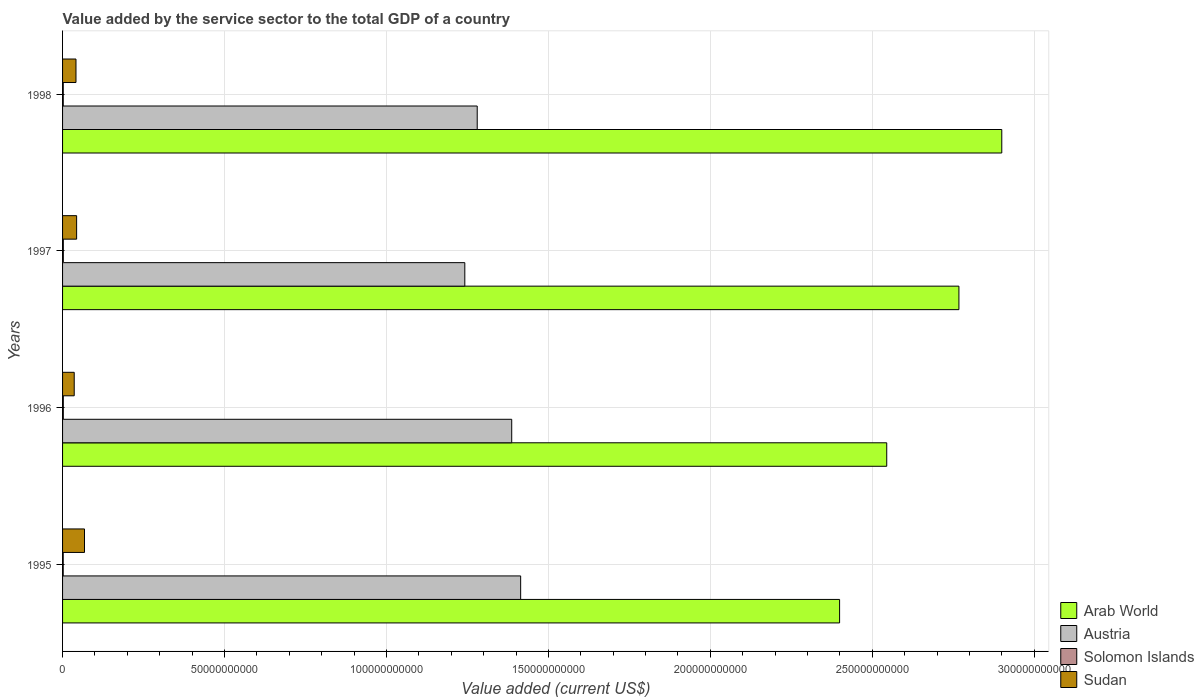How many groups of bars are there?
Make the answer very short. 4. Are the number of bars per tick equal to the number of legend labels?
Offer a very short reply. Yes. Are the number of bars on each tick of the Y-axis equal?
Your answer should be compact. Yes. What is the label of the 3rd group of bars from the top?
Your response must be concise. 1996. In how many cases, is the number of bars for a given year not equal to the number of legend labels?
Your answer should be compact. 0. What is the value added by the service sector to the total GDP in Arab World in 1998?
Keep it short and to the point. 2.90e+11. Across all years, what is the maximum value added by the service sector to the total GDP in Sudan?
Make the answer very short. 6.77e+09. Across all years, what is the minimum value added by the service sector to the total GDP in Solomon Islands?
Keep it short and to the point. 2.01e+08. In which year was the value added by the service sector to the total GDP in Solomon Islands maximum?
Provide a succinct answer. 1997. What is the total value added by the service sector to the total GDP in Sudan in the graph?
Offer a very short reply. 1.89e+1. What is the difference between the value added by the service sector to the total GDP in Arab World in 1995 and that in 1997?
Make the answer very short. -3.68e+1. What is the difference between the value added by the service sector to the total GDP in Austria in 1996 and the value added by the service sector to the total GDP in Arab World in 1997?
Offer a very short reply. -1.38e+11. What is the average value added by the service sector to the total GDP in Sudan per year?
Your response must be concise. 4.71e+09. In the year 1997, what is the difference between the value added by the service sector to the total GDP in Sudan and value added by the service sector to the total GDP in Arab World?
Ensure brevity in your answer.  -2.72e+11. In how many years, is the value added by the service sector to the total GDP in Austria greater than 70000000000 US$?
Your response must be concise. 4. What is the ratio of the value added by the service sector to the total GDP in Sudan in 1995 to that in 1998?
Your response must be concise. 1.63. What is the difference between the highest and the second highest value added by the service sector to the total GDP in Sudan?
Offer a very short reply. 2.43e+09. What is the difference between the highest and the lowest value added by the service sector to the total GDP in Arab World?
Provide a short and direct response. 5.01e+1. In how many years, is the value added by the service sector to the total GDP in Austria greater than the average value added by the service sector to the total GDP in Austria taken over all years?
Offer a terse response. 2. Is it the case that in every year, the sum of the value added by the service sector to the total GDP in Austria and value added by the service sector to the total GDP in Sudan is greater than the sum of value added by the service sector to the total GDP in Arab World and value added by the service sector to the total GDP in Solomon Islands?
Your answer should be very brief. No. What does the 4th bar from the top in 1997 represents?
Your answer should be very brief. Arab World. What does the 3rd bar from the bottom in 1996 represents?
Keep it short and to the point. Solomon Islands. Is it the case that in every year, the sum of the value added by the service sector to the total GDP in Arab World and value added by the service sector to the total GDP in Sudan is greater than the value added by the service sector to the total GDP in Solomon Islands?
Ensure brevity in your answer.  Yes. How many bars are there?
Make the answer very short. 16. Are all the bars in the graph horizontal?
Provide a succinct answer. Yes. How many years are there in the graph?
Make the answer very short. 4. Where does the legend appear in the graph?
Your response must be concise. Bottom right. What is the title of the graph?
Give a very brief answer. Value added by the service sector to the total GDP of a country. What is the label or title of the X-axis?
Offer a terse response. Value added (current US$). What is the label or title of the Y-axis?
Keep it short and to the point. Years. What is the Value added (current US$) in Arab World in 1995?
Your answer should be compact. 2.40e+11. What is the Value added (current US$) of Austria in 1995?
Make the answer very short. 1.41e+11. What is the Value added (current US$) of Solomon Islands in 1995?
Your answer should be very brief. 2.01e+08. What is the Value added (current US$) in Sudan in 1995?
Your answer should be compact. 6.77e+09. What is the Value added (current US$) of Arab World in 1996?
Provide a succinct answer. 2.54e+11. What is the Value added (current US$) in Austria in 1996?
Ensure brevity in your answer.  1.39e+11. What is the Value added (current US$) in Solomon Islands in 1996?
Your answer should be compact. 2.31e+08. What is the Value added (current US$) of Sudan in 1996?
Provide a short and direct response. 3.60e+09. What is the Value added (current US$) in Arab World in 1997?
Your answer should be compact. 2.77e+11. What is the Value added (current US$) in Austria in 1997?
Ensure brevity in your answer.  1.24e+11. What is the Value added (current US$) of Solomon Islands in 1997?
Provide a succinct answer. 2.37e+08. What is the Value added (current US$) of Sudan in 1997?
Your answer should be very brief. 4.34e+09. What is the Value added (current US$) of Arab World in 1998?
Keep it short and to the point. 2.90e+11. What is the Value added (current US$) of Austria in 1998?
Your answer should be very brief. 1.28e+11. What is the Value added (current US$) in Solomon Islands in 1998?
Your response must be concise. 2.17e+08. What is the Value added (current US$) of Sudan in 1998?
Your answer should be compact. 4.14e+09. Across all years, what is the maximum Value added (current US$) of Arab World?
Keep it short and to the point. 2.90e+11. Across all years, what is the maximum Value added (current US$) in Austria?
Give a very brief answer. 1.41e+11. Across all years, what is the maximum Value added (current US$) in Solomon Islands?
Your response must be concise. 2.37e+08. Across all years, what is the maximum Value added (current US$) in Sudan?
Offer a very short reply. 6.77e+09. Across all years, what is the minimum Value added (current US$) in Arab World?
Keep it short and to the point. 2.40e+11. Across all years, what is the minimum Value added (current US$) of Austria?
Provide a short and direct response. 1.24e+11. Across all years, what is the minimum Value added (current US$) of Solomon Islands?
Keep it short and to the point. 2.01e+08. Across all years, what is the minimum Value added (current US$) of Sudan?
Your answer should be very brief. 3.60e+09. What is the total Value added (current US$) in Arab World in the graph?
Give a very brief answer. 1.06e+12. What is the total Value added (current US$) of Austria in the graph?
Provide a succinct answer. 5.32e+11. What is the total Value added (current US$) in Solomon Islands in the graph?
Offer a very short reply. 8.87e+08. What is the total Value added (current US$) of Sudan in the graph?
Your answer should be very brief. 1.89e+1. What is the difference between the Value added (current US$) in Arab World in 1995 and that in 1996?
Keep it short and to the point. -1.46e+1. What is the difference between the Value added (current US$) of Austria in 1995 and that in 1996?
Your response must be concise. 2.76e+09. What is the difference between the Value added (current US$) in Solomon Islands in 1995 and that in 1996?
Your answer should be very brief. -2.99e+07. What is the difference between the Value added (current US$) of Sudan in 1995 and that in 1996?
Provide a short and direct response. 3.17e+09. What is the difference between the Value added (current US$) of Arab World in 1995 and that in 1997?
Your answer should be very brief. -3.68e+1. What is the difference between the Value added (current US$) in Austria in 1995 and that in 1997?
Offer a very short reply. 1.72e+1. What is the difference between the Value added (current US$) of Solomon Islands in 1995 and that in 1997?
Offer a very short reply. -3.56e+07. What is the difference between the Value added (current US$) of Sudan in 1995 and that in 1997?
Your answer should be very brief. 2.43e+09. What is the difference between the Value added (current US$) of Arab World in 1995 and that in 1998?
Your answer should be compact. -5.01e+1. What is the difference between the Value added (current US$) in Austria in 1995 and that in 1998?
Offer a very short reply. 1.34e+1. What is the difference between the Value added (current US$) in Solomon Islands in 1995 and that in 1998?
Ensure brevity in your answer.  -1.59e+07. What is the difference between the Value added (current US$) of Sudan in 1995 and that in 1998?
Provide a short and direct response. 2.63e+09. What is the difference between the Value added (current US$) of Arab World in 1996 and that in 1997?
Your response must be concise. -2.23e+1. What is the difference between the Value added (current US$) of Austria in 1996 and that in 1997?
Keep it short and to the point. 1.45e+1. What is the difference between the Value added (current US$) of Solomon Islands in 1996 and that in 1997?
Keep it short and to the point. -5.67e+06. What is the difference between the Value added (current US$) in Sudan in 1996 and that in 1997?
Make the answer very short. -7.44e+08. What is the difference between the Value added (current US$) in Arab World in 1996 and that in 1998?
Offer a terse response. -3.55e+1. What is the difference between the Value added (current US$) of Austria in 1996 and that in 1998?
Your answer should be compact. 1.07e+1. What is the difference between the Value added (current US$) in Solomon Islands in 1996 and that in 1998?
Your answer should be very brief. 1.40e+07. What is the difference between the Value added (current US$) in Sudan in 1996 and that in 1998?
Give a very brief answer. -5.45e+08. What is the difference between the Value added (current US$) of Arab World in 1997 and that in 1998?
Your answer should be very brief. -1.32e+1. What is the difference between the Value added (current US$) of Austria in 1997 and that in 1998?
Offer a very short reply. -3.83e+09. What is the difference between the Value added (current US$) of Solomon Islands in 1997 and that in 1998?
Give a very brief answer. 1.97e+07. What is the difference between the Value added (current US$) of Sudan in 1997 and that in 1998?
Your answer should be very brief. 1.99e+08. What is the difference between the Value added (current US$) in Arab World in 1995 and the Value added (current US$) in Austria in 1996?
Your answer should be compact. 1.01e+11. What is the difference between the Value added (current US$) in Arab World in 1995 and the Value added (current US$) in Solomon Islands in 1996?
Ensure brevity in your answer.  2.40e+11. What is the difference between the Value added (current US$) of Arab World in 1995 and the Value added (current US$) of Sudan in 1996?
Keep it short and to the point. 2.36e+11. What is the difference between the Value added (current US$) of Austria in 1995 and the Value added (current US$) of Solomon Islands in 1996?
Keep it short and to the point. 1.41e+11. What is the difference between the Value added (current US$) in Austria in 1995 and the Value added (current US$) in Sudan in 1996?
Offer a very short reply. 1.38e+11. What is the difference between the Value added (current US$) of Solomon Islands in 1995 and the Value added (current US$) of Sudan in 1996?
Provide a succinct answer. -3.40e+09. What is the difference between the Value added (current US$) of Arab World in 1995 and the Value added (current US$) of Austria in 1997?
Give a very brief answer. 1.16e+11. What is the difference between the Value added (current US$) in Arab World in 1995 and the Value added (current US$) in Solomon Islands in 1997?
Offer a very short reply. 2.40e+11. What is the difference between the Value added (current US$) in Arab World in 1995 and the Value added (current US$) in Sudan in 1997?
Your response must be concise. 2.36e+11. What is the difference between the Value added (current US$) of Austria in 1995 and the Value added (current US$) of Solomon Islands in 1997?
Offer a very short reply. 1.41e+11. What is the difference between the Value added (current US$) of Austria in 1995 and the Value added (current US$) of Sudan in 1997?
Keep it short and to the point. 1.37e+11. What is the difference between the Value added (current US$) in Solomon Islands in 1995 and the Value added (current US$) in Sudan in 1997?
Keep it short and to the point. -4.14e+09. What is the difference between the Value added (current US$) of Arab World in 1995 and the Value added (current US$) of Austria in 1998?
Make the answer very short. 1.12e+11. What is the difference between the Value added (current US$) in Arab World in 1995 and the Value added (current US$) in Solomon Islands in 1998?
Provide a succinct answer. 2.40e+11. What is the difference between the Value added (current US$) in Arab World in 1995 and the Value added (current US$) in Sudan in 1998?
Provide a short and direct response. 2.36e+11. What is the difference between the Value added (current US$) of Austria in 1995 and the Value added (current US$) of Solomon Islands in 1998?
Ensure brevity in your answer.  1.41e+11. What is the difference between the Value added (current US$) of Austria in 1995 and the Value added (current US$) of Sudan in 1998?
Your response must be concise. 1.37e+11. What is the difference between the Value added (current US$) of Solomon Islands in 1995 and the Value added (current US$) of Sudan in 1998?
Offer a very short reply. -3.94e+09. What is the difference between the Value added (current US$) of Arab World in 1996 and the Value added (current US$) of Austria in 1997?
Your answer should be compact. 1.30e+11. What is the difference between the Value added (current US$) in Arab World in 1996 and the Value added (current US$) in Solomon Islands in 1997?
Your answer should be compact. 2.54e+11. What is the difference between the Value added (current US$) in Arab World in 1996 and the Value added (current US$) in Sudan in 1997?
Provide a succinct answer. 2.50e+11. What is the difference between the Value added (current US$) in Austria in 1996 and the Value added (current US$) in Solomon Islands in 1997?
Offer a terse response. 1.38e+11. What is the difference between the Value added (current US$) in Austria in 1996 and the Value added (current US$) in Sudan in 1997?
Your answer should be compact. 1.34e+11. What is the difference between the Value added (current US$) in Solomon Islands in 1996 and the Value added (current US$) in Sudan in 1997?
Ensure brevity in your answer.  -4.11e+09. What is the difference between the Value added (current US$) in Arab World in 1996 and the Value added (current US$) in Austria in 1998?
Your answer should be compact. 1.26e+11. What is the difference between the Value added (current US$) in Arab World in 1996 and the Value added (current US$) in Solomon Islands in 1998?
Provide a succinct answer. 2.54e+11. What is the difference between the Value added (current US$) of Arab World in 1996 and the Value added (current US$) of Sudan in 1998?
Offer a very short reply. 2.50e+11. What is the difference between the Value added (current US$) in Austria in 1996 and the Value added (current US$) in Solomon Islands in 1998?
Offer a terse response. 1.38e+11. What is the difference between the Value added (current US$) in Austria in 1996 and the Value added (current US$) in Sudan in 1998?
Provide a short and direct response. 1.35e+11. What is the difference between the Value added (current US$) in Solomon Islands in 1996 and the Value added (current US$) in Sudan in 1998?
Offer a very short reply. -3.91e+09. What is the difference between the Value added (current US$) in Arab World in 1997 and the Value added (current US$) in Austria in 1998?
Make the answer very short. 1.49e+11. What is the difference between the Value added (current US$) in Arab World in 1997 and the Value added (current US$) in Solomon Islands in 1998?
Offer a terse response. 2.77e+11. What is the difference between the Value added (current US$) in Arab World in 1997 and the Value added (current US$) in Sudan in 1998?
Keep it short and to the point. 2.73e+11. What is the difference between the Value added (current US$) in Austria in 1997 and the Value added (current US$) in Solomon Islands in 1998?
Your answer should be compact. 1.24e+11. What is the difference between the Value added (current US$) of Austria in 1997 and the Value added (current US$) of Sudan in 1998?
Your answer should be very brief. 1.20e+11. What is the difference between the Value added (current US$) in Solomon Islands in 1997 and the Value added (current US$) in Sudan in 1998?
Give a very brief answer. -3.91e+09. What is the average Value added (current US$) in Arab World per year?
Provide a short and direct response. 2.65e+11. What is the average Value added (current US$) of Austria per year?
Ensure brevity in your answer.  1.33e+11. What is the average Value added (current US$) in Solomon Islands per year?
Your answer should be compact. 2.22e+08. What is the average Value added (current US$) of Sudan per year?
Provide a succinct answer. 4.71e+09. In the year 1995, what is the difference between the Value added (current US$) in Arab World and Value added (current US$) in Austria?
Offer a very short reply. 9.85e+1. In the year 1995, what is the difference between the Value added (current US$) of Arab World and Value added (current US$) of Solomon Islands?
Keep it short and to the point. 2.40e+11. In the year 1995, what is the difference between the Value added (current US$) in Arab World and Value added (current US$) in Sudan?
Offer a terse response. 2.33e+11. In the year 1995, what is the difference between the Value added (current US$) in Austria and Value added (current US$) in Solomon Islands?
Your answer should be compact. 1.41e+11. In the year 1995, what is the difference between the Value added (current US$) in Austria and Value added (current US$) in Sudan?
Your answer should be compact. 1.35e+11. In the year 1995, what is the difference between the Value added (current US$) in Solomon Islands and Value added (current US$) in Sudan?
Ensure brevity in your answer.  -6.57e+09. In the year 1996, what is the difference between the Value added (current US$) of Arab World and Value added (current US$) of Austria?
Offer a very short reply. 1.16e+11. In the year 1996, what is the difference between the Value added (current US$) of Arab World and Value added (current US$) of Solomon Islands?
Provide a short and direct response. 2.54e+11. In the year 1996, what is the difference between the Value added (current US$) of Arab World and Value added (current US$) of Sudan?
Make the answer very short. 2.51e+11. In the year 1996, what is the difference between the Value added (current US$) in Austria and Value added (current US$) in Solomon Islands?
Your response must be concise. 1.38e+11. In the year 1996, what is the difference between the Value added (current US$) in Austria and Value added (current US$) in Sudan?
Make the answer very short. 1.35e+11. In the year 1996, what is the difference between the Value added (current US$) of Solomon Islands and Value added (current US$) of Sudan?
Ensure brevity in your answer.  -3.37e+09. In the year 1997, what is the difference between the Value added (current US$) in Arab World and Value added (current US$) in Austria?
Keep it short and to the point. 1.53e+11. In the year 1997, what is the difference between the Value added (current US$) of Arab World and Value added (current US$) of Solomon Islands?
Provide a succinct answer. 2.77e+11. In the year 1997, what is the difference between the Value added (current US$) in Arab World and Value added (current US$) in Sudan?
Provide a short and direct response. 2.72e+11. In the year 1997, what is the difference between the Value added (current US$) of Austria and Value added (current US$) of Solomon Islands?
Make the answer very short. 1.24e+11. In the year 1997, what is the difference between the Value added (current US$) of Austria and Value added (current US$) of Sudan?
Offer a terse response. 1.20e+11. In the year 1997, what is the difference between the Value added (current US$) of Solomon Islands and Value added (current US$) of Sudan?
Offer a very short reply. -4.10e+09. In the year 1998, what is the difference between the Value added (current US$) of Arab World and Value added (current US$) of Austria?
Ensure brevity in your answer.  1.62e+11. In the year 1998, what is the difference between the Value added (current US$) in Arab World and Value added (current US$) in Solomon Islands?
Give a very brief answer. 2.90e+11. In the year 1998, what is the difference between the Value added (current US$) in Arab World and Value added (current US$) in Sudan?
Provide a short and direct response. 2.86e+11. In the year 1998, what is the difference between the Value added (current US$) in Austria and Value added (current US$) in Solomon Islands?
Offer a very short reply. 1.28e+11. In the year 1998, what is the difference between the Value added (current US$) of Austria and Value added (current US$) of Sudan?
Your answer should be very brief. 1.24e+11. In the year 1998, what is the difference between the Value added (current US$) in Solomon Islands and Value added (current US$) in Sudan?
Give a very brief answer. -3.93e+09. What is the ratio of the Value added (current US$) of Arab World in 1995 to that in 1996?
Make the answer very short. 0.94. What is the ratio of the Value added (current US$) of Austria in 1995 to that in 1996?
Offer a terse response. 1.02. What is the ratio of the Value added (current US$) of Solomon Islands in 1995 to that in 1996?
Make the answer very short. 0.87. What is the ratio of the Value added (current US$) in Sudan in 1995 to that in 1996?
Make the answer very short. 1.88. What is the ratio of the Value added (current US$) of Arab World in 1995 to that in 1997?
Ensure brevity in your answer.  0.87. What is the ratio of the Value added (current US$) in Austria in 1995 to that in 1997?
Give a very brief answer. 1.14. What is the ratio of the Value added (current US$) of Solomon Islands in 1995 to that in 1997?
Your response must be concise. 0.85. What is the ratio of the Value added (current US$) in Sudan in 1995 to that in 1997?
Keep it short and to the point. 1.56. What is the ratio of the Value added (current US$) in Arab World in 1995 to that in 1998?
Provide a succinct answer. 0.83. What is the ratio of the Value added (current US$) in Austria in 1995 to that in 1998?
Offer a very short reply. 1.1. What is the ratio of the Value added (current US$) in Solomon Islands in 1995 to that in 1998?
Ensure brevity in your answer.  0.93. What is the ratio of the Value added (current US$) in Sudan in 1995 to that in 1998?
Keep it short and to the point. 1.63. What is the ratio of the Value added (current US$) of Arab World in 1996 to that in 1997?
Offer a terse response. 0.92. What is the ratio of the Value added (current US$) of Austria in 1996 to that in 1997?
Keep it short and to the point. 1.12. What is the ratio of the Value added (current US$) of Solomon Islands in 1996 to that in 1997?
Make the answer very short. 0.98. What is the ratio of the Value added (current US$) in Sudan in 1996 to that in 1997?
Offer a very short reply. 0.83. What is the ratio of the Value added (current US$) in Arab World in 1996 to that in 1998?
Provide a short and direct response. 0.88. What is the ratio of the Value added (current US$) of Austria in 1996 to that in 1998?
Your response must be concise. 1.08. What is the ratio of the Value added (current US$) of Solomon Islands in 1996 to that in 1998?
Provide a succinct answer. 1.06. What is the ratio of the Value added (current US$) in Sudan in 1996 to that in 1998?
Provide a succinct answer. 0.87. What is the ratio of the Value added (current US$) of Arab World in 1997 to that in 1998?
Your response must be concise. 0.95. What is the ratio of the Value added (current US$) of Austria in 1997 to that in 1998?
Make the answer very short. 0.97. What is the ratio of the Value added (current US$) of Solomon Islands in 1997 to that in 1998?
Make the answer very short. 1.09. What is the ratio of the Value added (current US$) of Sudan in 1997 to that in 1998?
Provide a short and direct response. 1.05. What is the difference between the highest and the second highest Value added (current US$) in Arab World?
Offer a terse response. 1.32e+1. What is the difference between the highest and the second highest Value added (current US$) in Austria?
Offer a very short reply. 2.76e+09. What is the difference between the highest and the second highest Value added (current US$) of Solomon Islands?
Your answer should be compact. 5.67e+06. What is the difference between the highest and the second highest Value added (current US$) in Sudan?
Give a very brief answer. 2.43e+09. What is the difference between the highest and the lowest Value added (current US$) of Arab World?
Keep it short and to the point. 5.01e+1. What is the difference between the highest and the lowest Value added (current US$) in Austria?
Provide a short and direct response. 1.72e+1. What is the difference between the highest and the lowest Value added (current US$) in Solomon Islands?
Your answer should be compact. 3.56e+07. What is the difference between the highest and the lowest Value added (current US$) in Sudan?
Keep it short and to the point. 3.17e+09. 